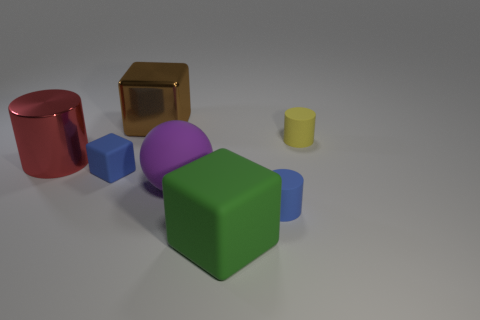The small matte object that is in front of the red metal cylinder and to the right of the large brown metallic cube has what shape?
Your response must be concise. Cylinder. Are there fewer purple things than gray shiny cylinders?
Provide a short and direct response. No. Is there a small blue shiny ball?
Make the answer very short. No. How many other objects are the same size as the blue cylinder?
Provide a succinct answer. 2. Does the large red cylinder have the same material as the object behind the tiny yellow matte cylinder?
Provide a short and direct response. Yes. Is the number of brown metal objects in front of the big metallic block the same as the number of things that are to the left of the large red thing?
Your answer should be very brief. Yes. What is the big purple thing made of?
Offer a terse response. Rubber. There is a shiny block that is the same size as the red cylinder; what color is it?
Provide a succinct answer. Brown. There is a big shiny thing that is in front of the shiny block; are there any red shiny objects on the left side of it?
Your answer should be compact. No. How many spheres are brown metal things or blue things?
Your response must be concise. 0. 